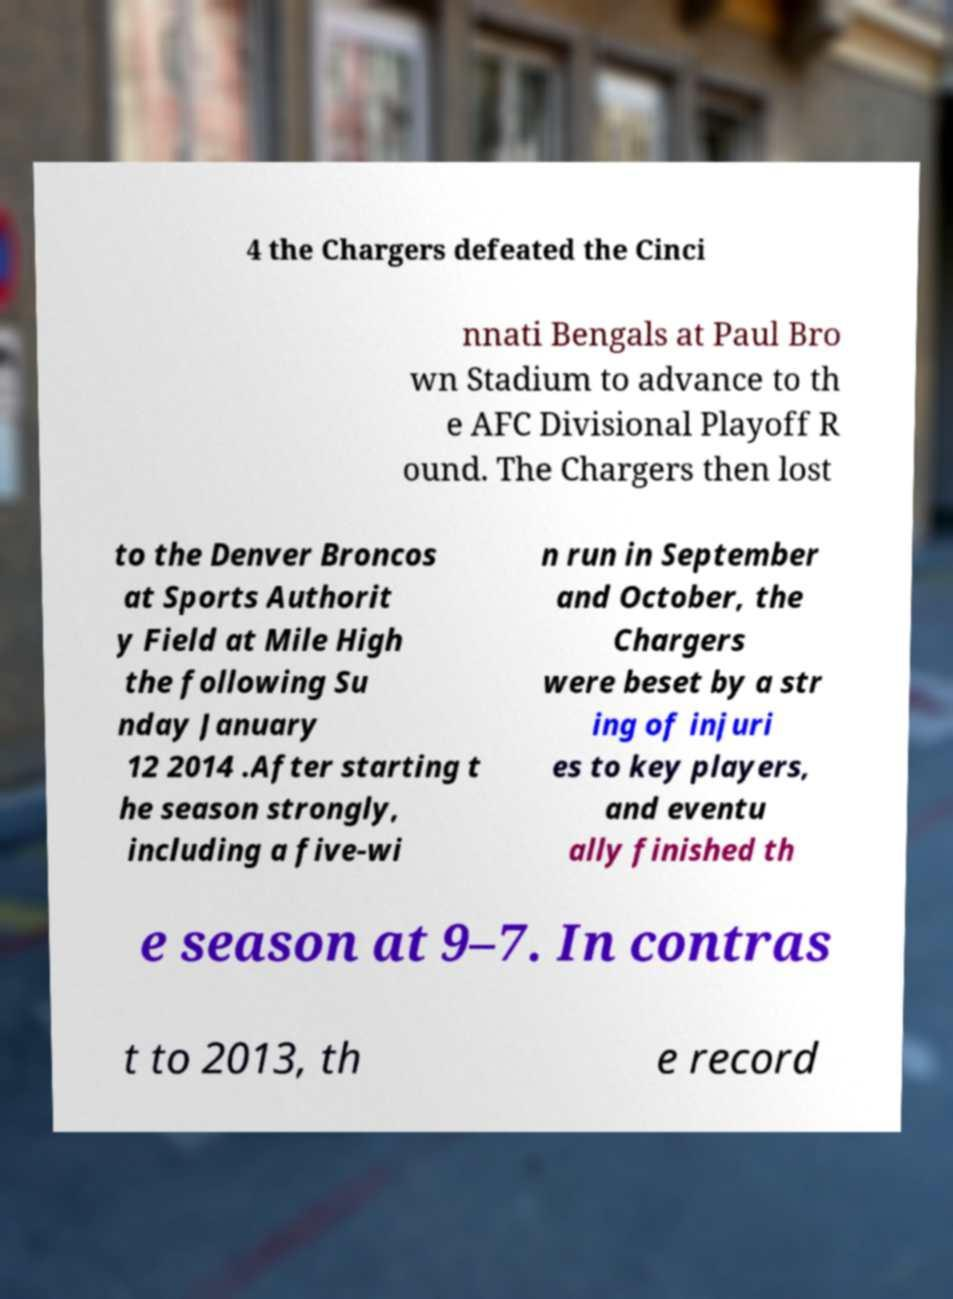Could you extract and type out the text from this image? 4 the Chargers defeated the Cinci nnati Bengals at Paul Bro wn Stadium to advance to th e AFC Divisional Playoff R ound. The Chargers then lost to the Denver Broncos at Sports Authorit y Field at Mile High the following Su nday January 12 2014 .After starting t he season strongly, including a five-wi n run in September and October, the Chargers were beset by a str ing of injuri es to key players, and eventu ally finished th e season at 9–7. In contras t to 2013, th e record 